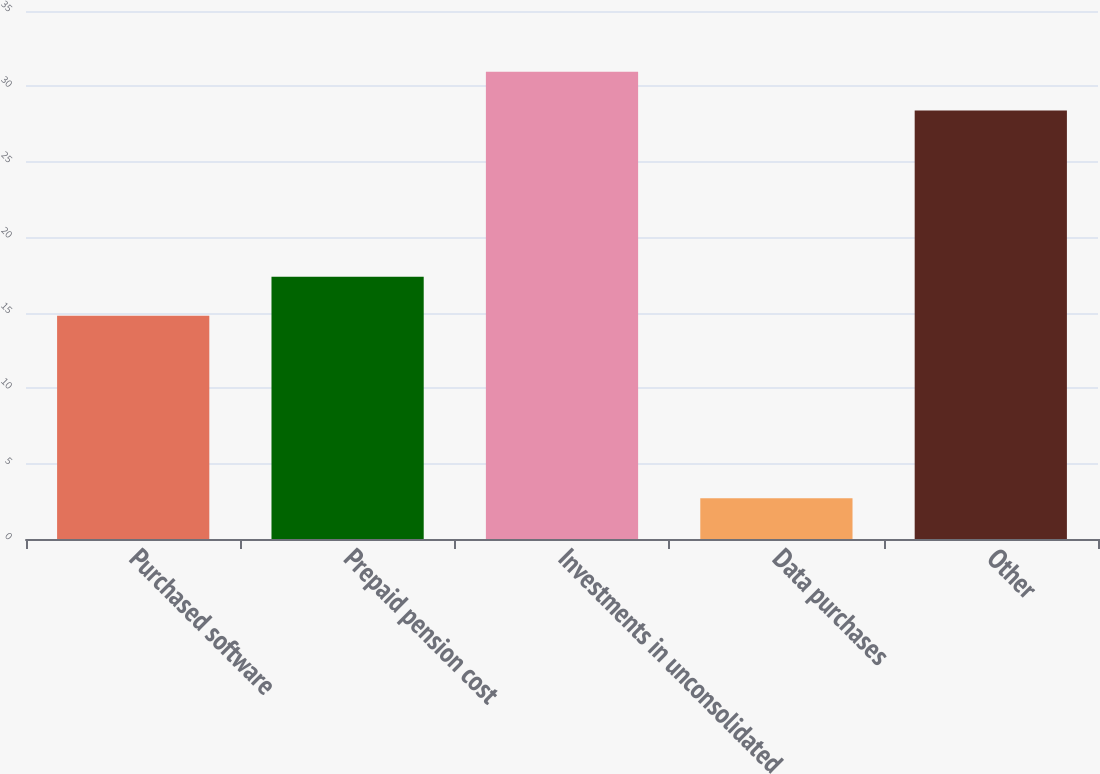<chart> <loc_0><loc_0><loc_500><loc_500><bar_chart><fcel>Purchased software<fcel>Prepaid pension cost<fcel>Investments in unconsolidated<fcel>Data purchases<fcel>Other<nl><fcel>14.8<fcel>17.38<fcel>30.98<fcel>2.7<fcel>28.4<nl></chart> 